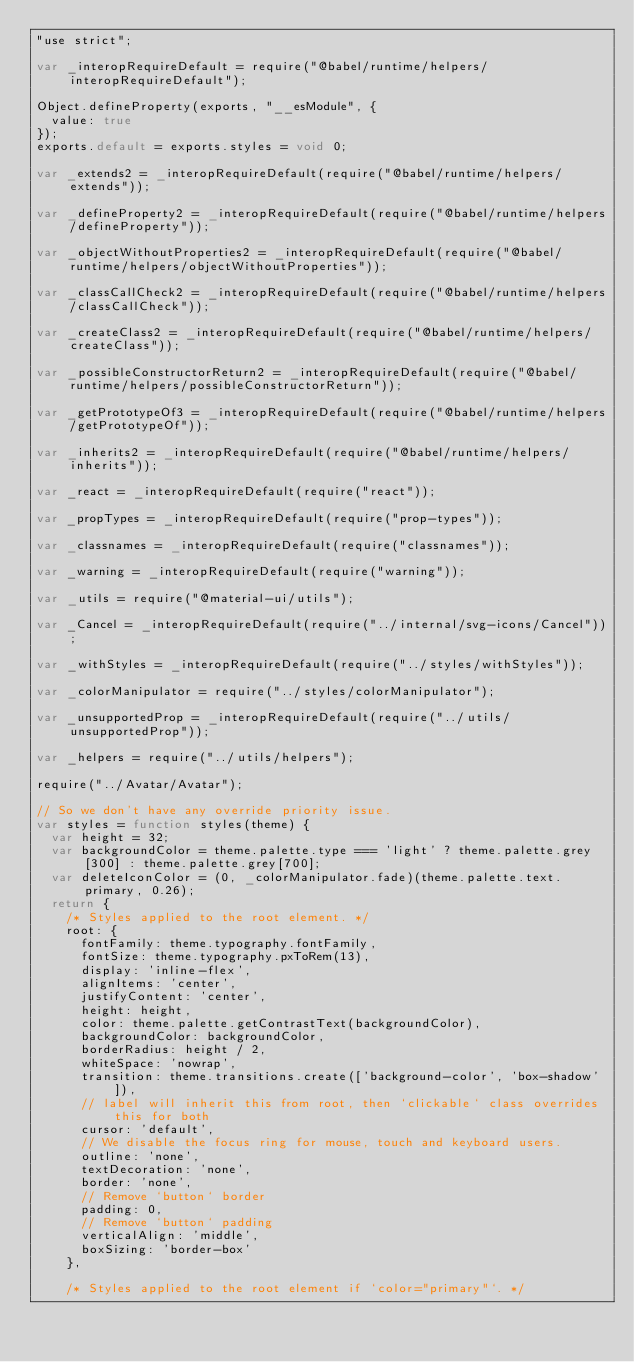<code> <loc_0><loc_0><loc_500><loc_500><_JavaScript_>"use strict";

var _interopRequireDefault = require("@babel/runtime/helpers/interopRequireDefault");

Object.defineProperty(exports, "__esModule", {
  value: true
});
exports.default = exports.styles = void 0;

var _extends2 = _interopRequireDefault(require("@babel/runtime/helpers/extends"));

var _defineProperty2 = _interopRequireDefault(require("@babel/runtime/helpers/defineProperty"));

var _objectWithoutProperties2 = _interopRequireDefault(require("@babel/runtime/helpers/objectWithoutProperties"));

var _classCallCheck2 = _interopRequireDefault(require("@babel/runtime/helpers/classCallCheck"));

var _createClass2 = _interopRequireDefault(require("@babel/runtime/helpers/createClass"));

var _possibleConstructorReturn2 = _interopRequireDefault(require("@babel/runtime/helpers/possibleConstructorReturn"));

var _getPrototypeOf3 = _interopRequireDefault(require("@babel/runtime/helpers/getPrototypeOf"));

var _inherits2 = _interopRequireDefault(require("@babel/runtime/helpers/inherits"));

var _react = _interopRequireDefault(require("react"));

var _propTypes = _interopRequireDefault(require("prop-types"));

var _classnames = _interopRequireDefault(require("classnames"));

var _warning = _interopRequireDefault(require("warning"));

var _utils = require("@material-ui/utils");

var _Cancel = _interopRequireDefault(require("../internal/svg-icons/Cancel"));

var _withStyles = _interopRequireDefault(require("../styles/withStyles"));

var _colorManipulator = require("../styles/colorManipulator");

var _unsupportedProp = _interopRequireDefault(require("../utils/unsupportedProp"));

var _helpers = require("../utils/helpers");

require("../Avatar/Avatar");

// So we don't have any override priority issue.
var styles = function styles(theme) {
  var height = 32;
  var backgroundColor = theme.palette.type === 'light' ? theme.palette.grey[300] : theme.palette.grey[700];
  var deleteIconColor = (0, _colorManipulator.fade)(theme.palette.text.primary, 0.26);
  return {
    /* Styles applied to the root element. */
    root: {
      fontFamily: theme.typography.fontFamily,
      fontSize: theme.typography.pxToRem(13),
      display: 'inline-flex',
      alignItems: 'center',
      justifyContent: 'center',
      height: height,
      color: theme.palette.getContrastText(backgroundColor),
      backgroundColor: backgroundColor,
      borderRadius: height / 2,
      whiteSpace: 'nowrap',
      transition: theme.transitions.create(['background-color', 'box-shadow']),
      // label will inherit this from root, then `clickable` class overrides this for both
      cursor: 'default',
      // We disable the focus ring for mouse, touch and keyboard users.
      outline: 'none',
      textDecoration: 'none',
      border: 'none',
      // Remove `button` border
      padding: 0,
      // Remove `button` padding
      verticalAlign: 'middle',
      boxSizing: 'border-box'
    },

    /* Styles applied to the root element if `color="primary"`. */</code> 